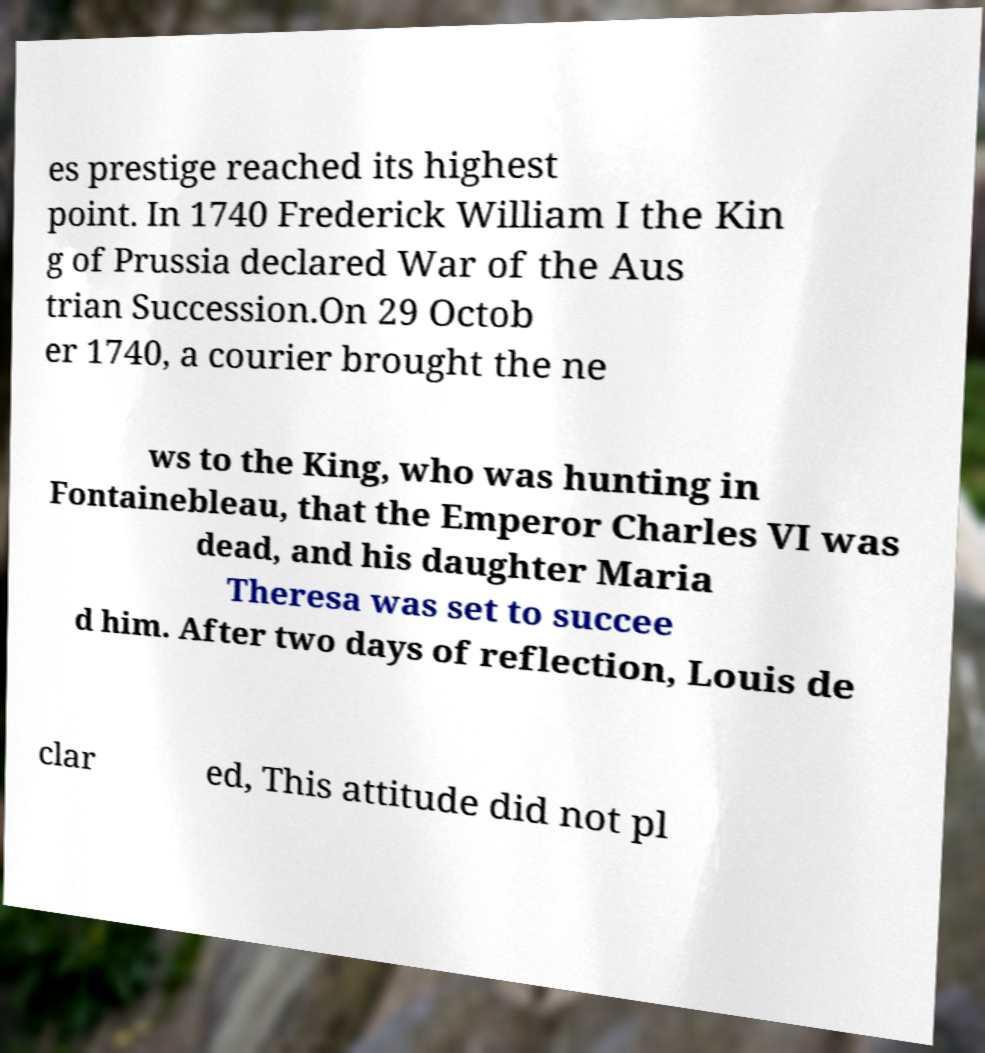For documentation purposes, I need the text within this image transcribed. Could you provide that? es prestige reached its highest point. In 1740 Frederick William I the Kin g of Prussia declared War of the Aus trian Succession.On 29 Octob er 1740, a courier brought the ne ws to the King, who was hunting in Fontainebleau, that the Emperor Charles VI was dead, and his daughter Maria Theresa was set to succee d him. After two days of reflection, Louis de clar ed, This attitude did not pl 